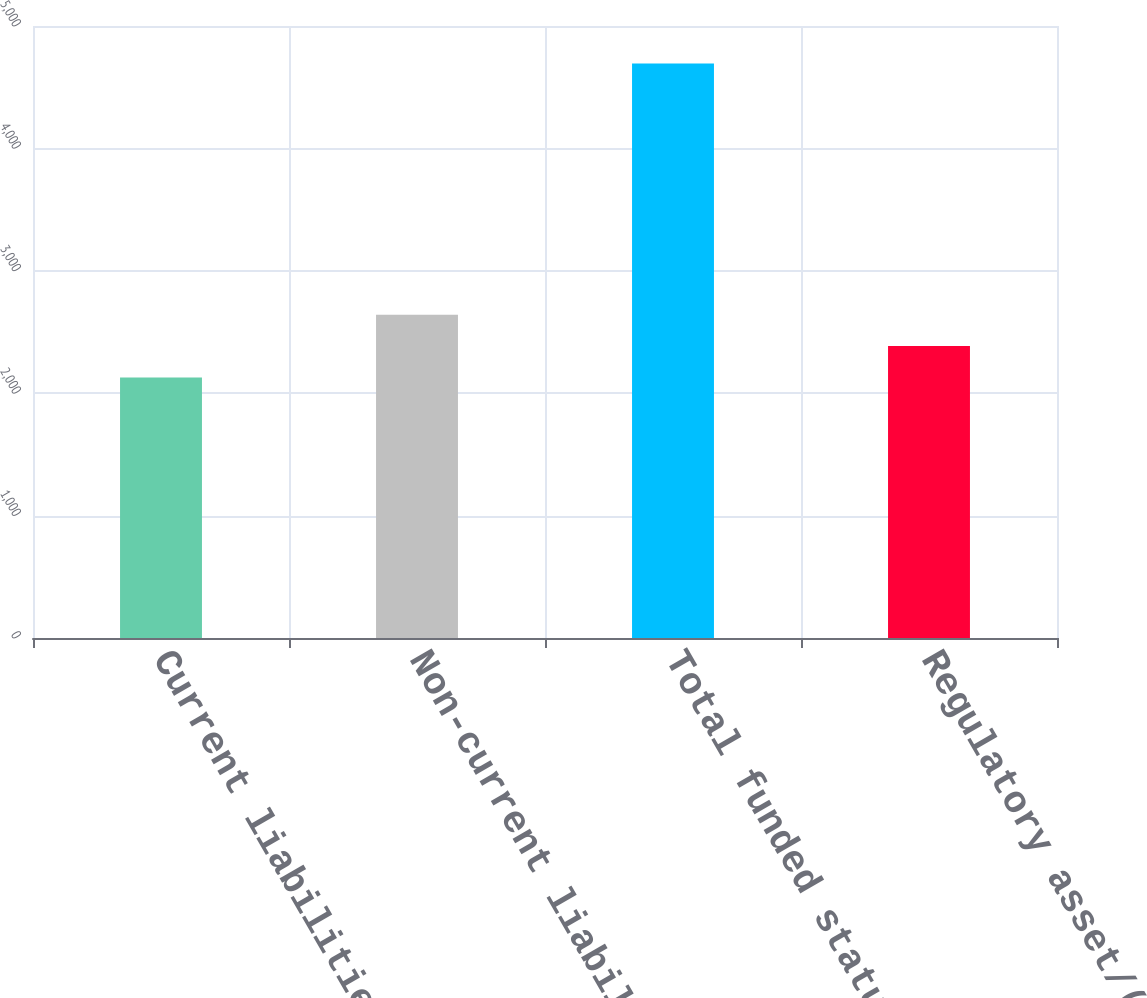Convert chart to OTSL. <chart><loc_0><loc_0><loc_500><loc_500><bar_chart><fcel>Current liabilities<fcel>Non-current liabilities<fcel>Total funded status<fcel>Regulatory asset/(liability)<nl><fcel>2128<fcel>2641.2<fcel>4694<fcel>2384.6<nl></chart> 